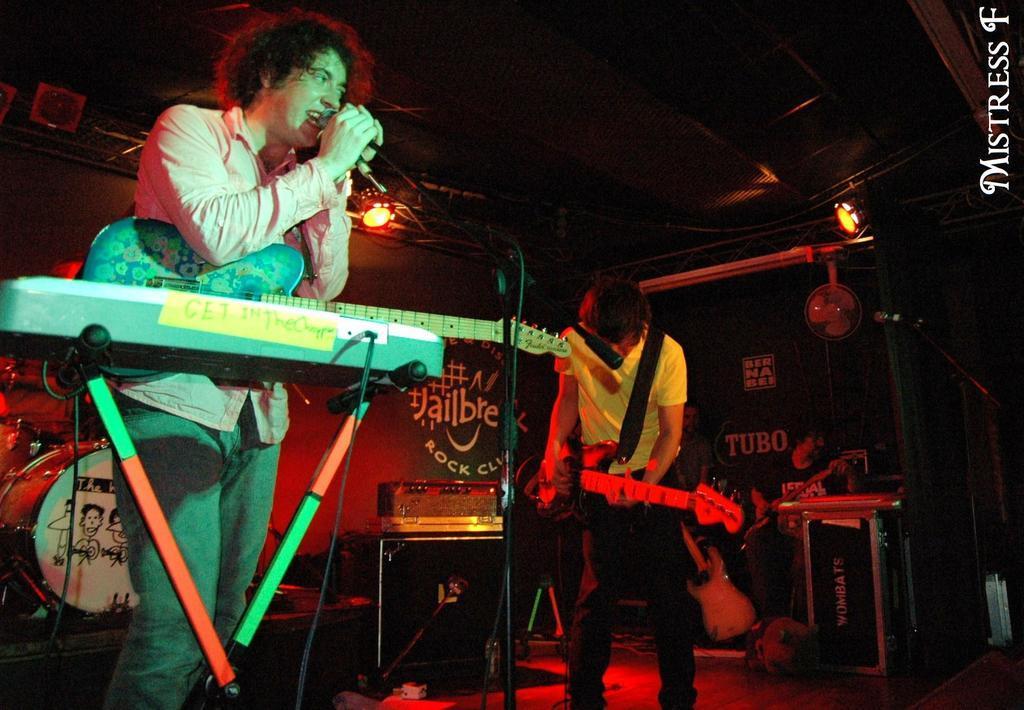How would you summarize this image in a sentence or two? This picture is clicked in a musical concert. Man on left corner of the picture wearing pink shirt is holding microphone in his hands and singing on it. Beside him, man in yellow t-shirt is holding guitar in his hands and playing it. Behind them, we see a table on which keyboard is placed and we even see a board with some text written on it is placed on red color wall. 